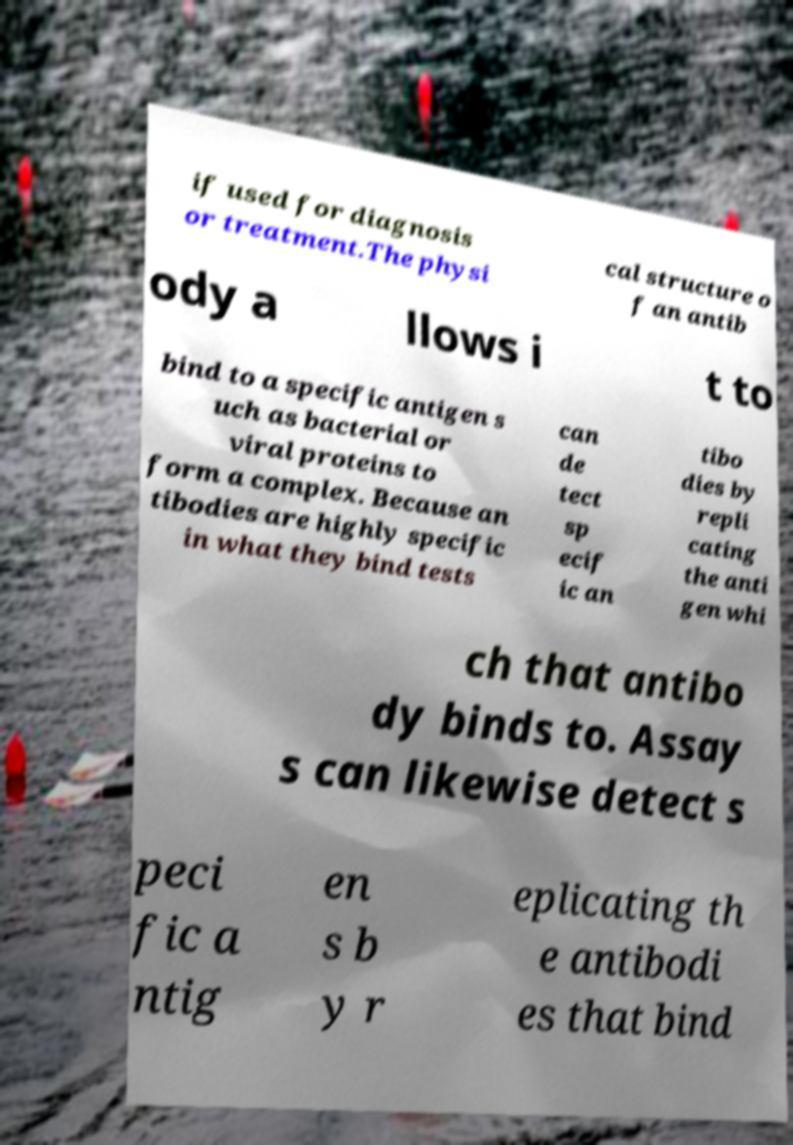Please read and relay the text visible in this image. What does it say? if used for diagnosis or treatment.The physi cal structure o f an antib ody a llows i t to bind to a specific antigen s uch as bacterial or viral proteins to form a complex. Because an tibodies are highly specific in what they bind tests can de tect sp ecif ic an tibo dies by repli cating the anti gen whi ch that antibo dy binds to. Assay s can likewise detect s peci fic a ntig en s b y r eplicating th e antibodi es that bind 